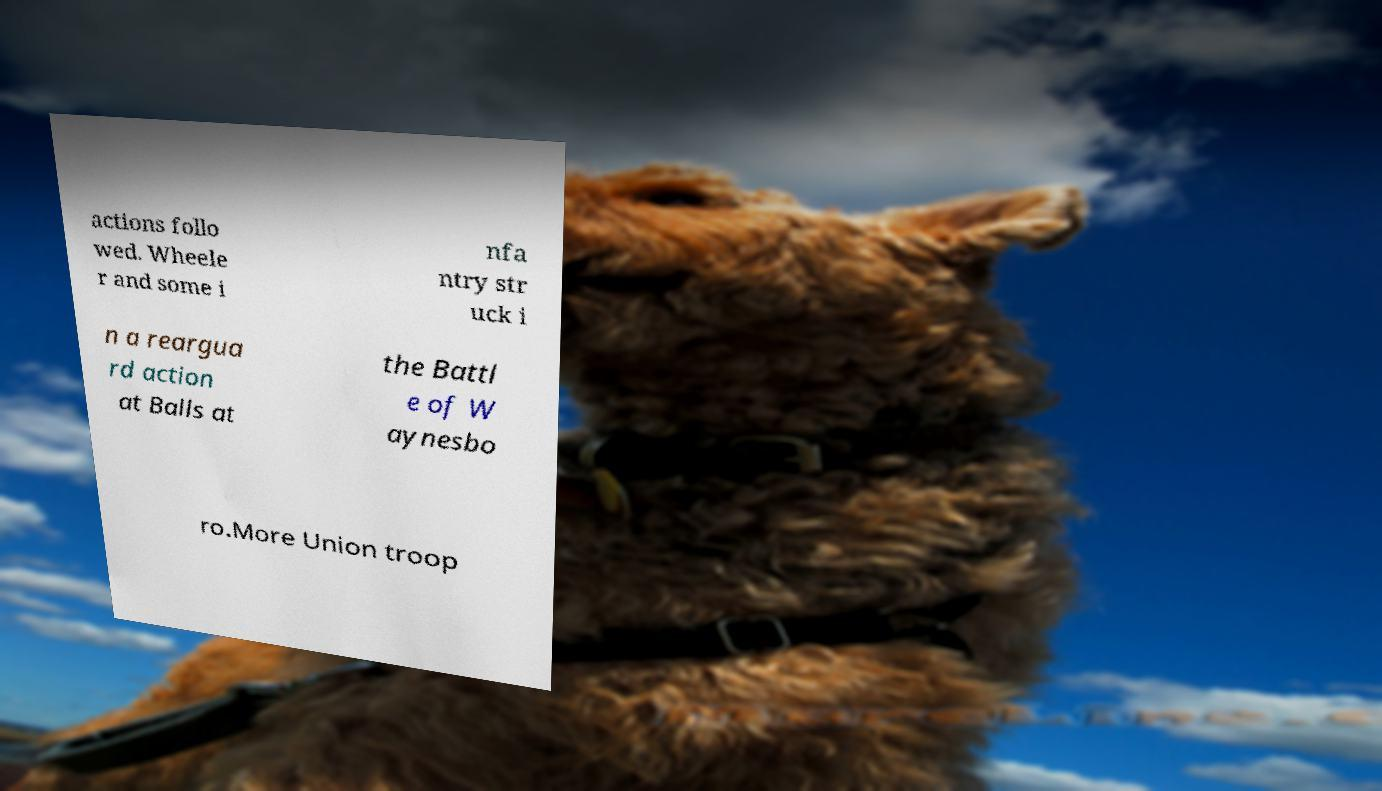What messages or text are displayed in this image? I need them in a readable, typed format. actions follo wed. Wheele r and some i nfa ntry str uck i n a reargua rd action at Balls at the Battl e of W aynesbo ro.More Union troop 